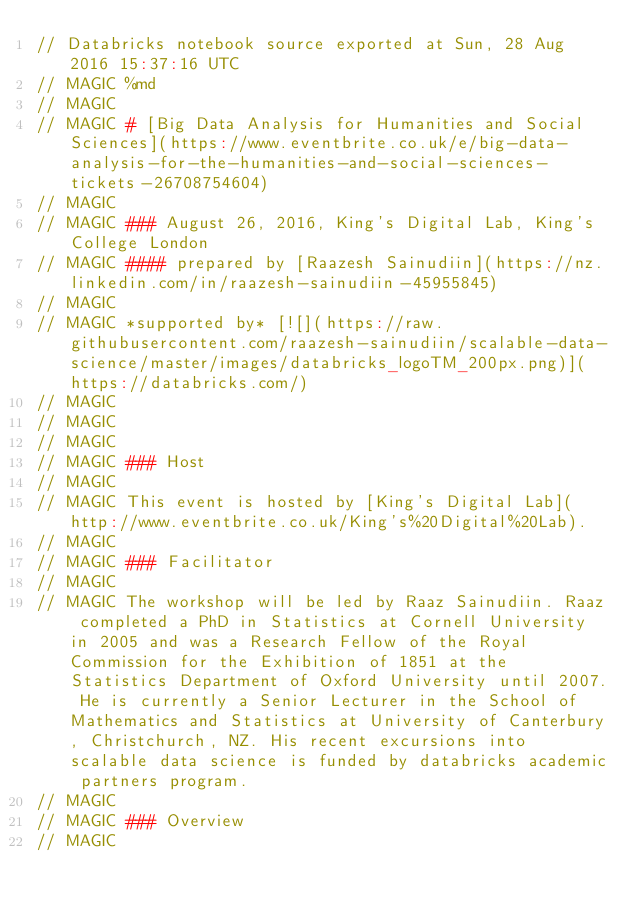<code> <loc_0><loc_0><loc_500><loc_500><_Scala_>// Databricks notebook source exported at Sun, 28 Aug 2016 15:37:16 UTC
// MAGIC %md
// MAGIC 
// MAGIC # [Big Data Analysis for Humanities and Social Sciences](https://www.eventbrite.co.uk/e/big-data-analysis-for-the-humanities-and-social-sciences-tickets-26708754604)
// MAGIC 
// MAGIC ### August 26, 2016, King's Digital Lab, King's College London
// MAGIC #### prepared by [Raazesh Sainudiin](https://nz.linkedin.com/in/raazesh-sainudiin-45955845) 
// MAGIC 
// MAGIC *supported by* [![](https://raw.githubusercontent.com/raazesh-sainudiin/scalable-data-science/master/images/databricks_logoTM_200px.png)](https://databricks.com/)
// MAGIC 
// MAGIC 
// MAGIC 
// MAGIC ### Host
// MAGIC 
// MAGIC This event is hosted by [King's Digital Lab](http://www.eventbrite.co.uk/King's%20Digital%20Lab).
// MAGIC 
// MAGIC ### Facilitator
// MAGIC 
// MAGIC The workshop will be led by Raaz Sainudiin. Raaz completed a PhD in Statistics at Cornell University in 2005 and was a Research Fellow of the Royal Commission for the Exhibition of 1851 at the Statistics Department of Oxford University until 2007. He is currently a Senior Lecturer in the School of Mathematics and Statistics at University of Canterbury, Christchurch, NZ. His recent excursions into scalable data science is funded by databricks academic partners program.
// MAGIC 
// MAGIC ### Overview
// MAGIC </code> 